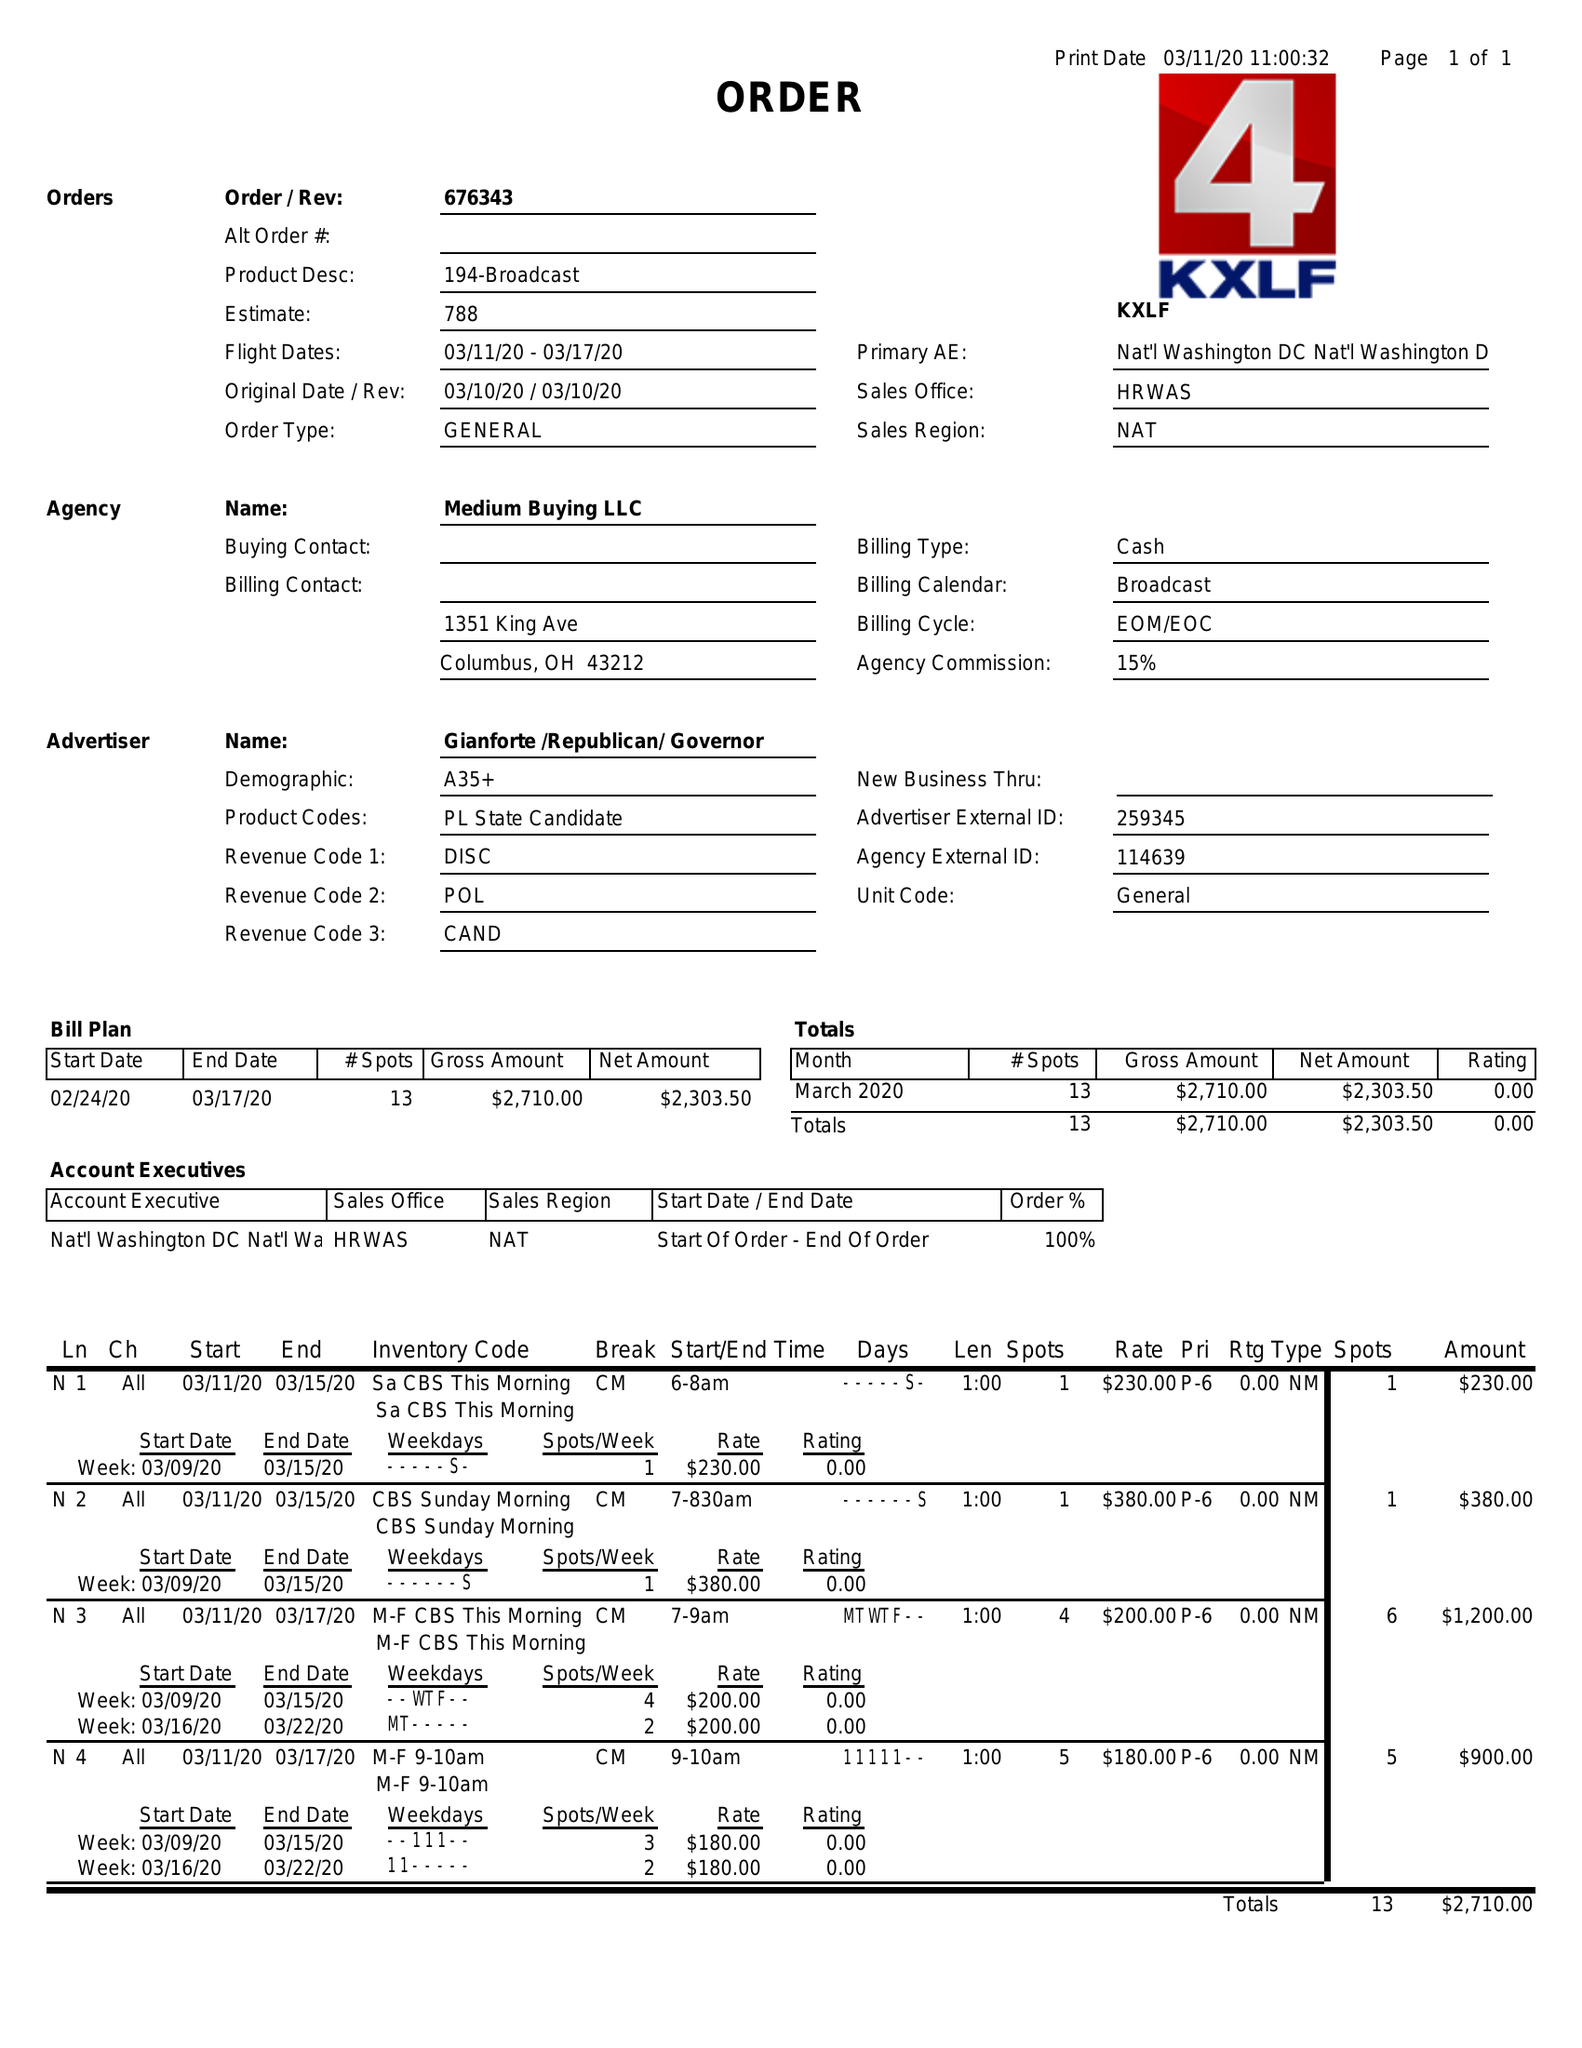What is the value for the gross_amount?
Answer the question using a single word or phrase. 2710.00 